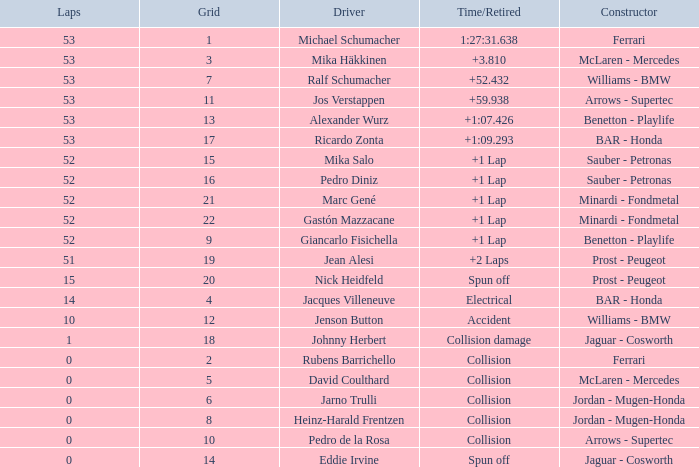What is the name of the driver with a grid less than 14, laps smaller than 53 and a Time/Retired of collision, and a Constructor of ferrari? Rubens Barrichello. 